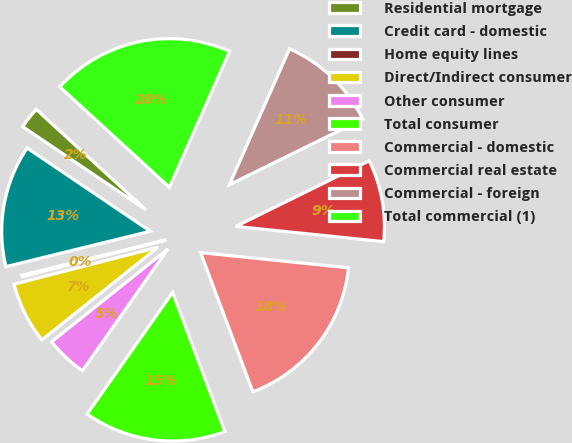Convert chart. <chart><loc_0><loc_0><loc_500><loc_500><pie_chart><fcel>Residential mortgage<fcel>Credit card - domestic<fcel>Home equity lines<fcel>Direct/Indirect consumer<fcel>Other consumer<fcel>Total consumer<fcel>Commercial - domestic<fcel>Commercial real estate<fcel>Commercial - foreign<fcel>Total commercial (1)<nl><fcel>2.35%<fcel>13.28%<fcel>0.17%<fcel>6.72%<fcel>4.54%<fcel>15.46%<fcel>17.65%<fcel>8.91%<fcel>11.09%<fcel>19.83%<nl></chart> 